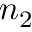Convert formula to latex. <formula><loc_0><loc_0><loc_500><loc_500>n _ { 2 }</formula> 